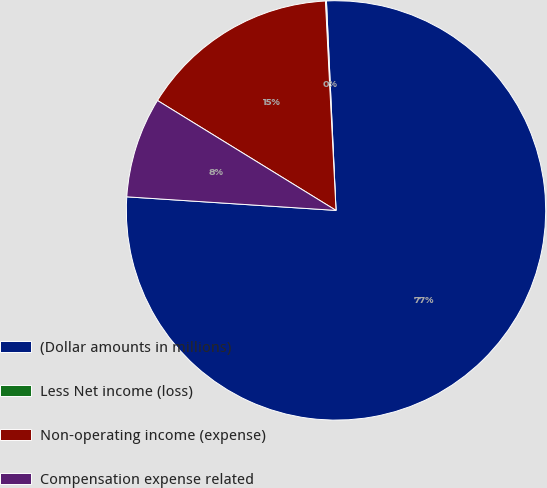<chart> <loc_0><loc_0><loc_500><loc_500><pie_chart><fcel>(Dollar amounts in millions)<fcel>Less Net income (loss)<fcel>Non-operating income (expense)<fcel>Compensation expense related<nl><fcel>76.76%<fcel>0.08%<fcel>15.41%<fcel>7.75%<nl></chart> 